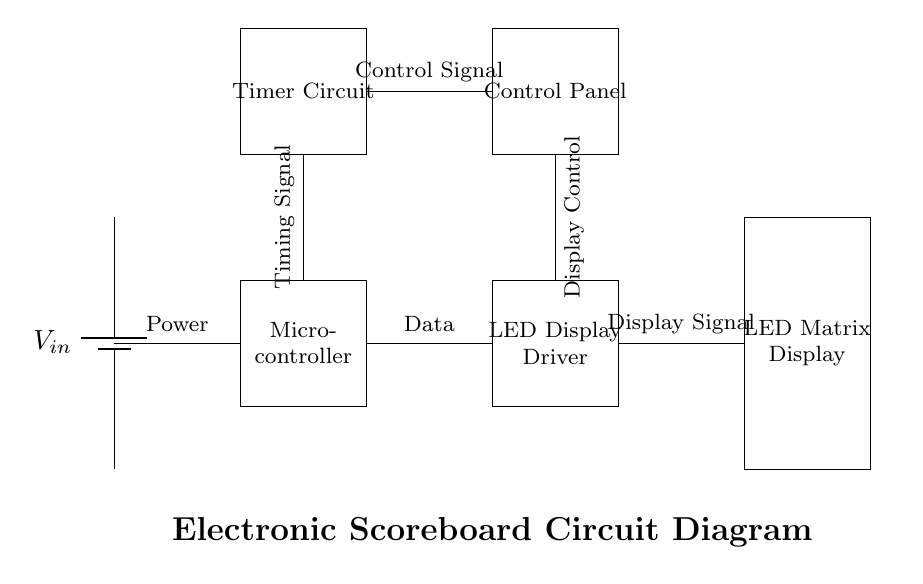What is the main function of the micro-controller in this circuit? The micro-controller processes data and sends control signals to both the LED display driver and the timer circuit, orchestrating the scoreboard's operations.
Answer: Data processing What type of display is utilized in this circuit? The circuit features an LED matrix display, indicated by the labeled rectangle representing this component in the diagram.
Answer: LED matrix display How many main components are present in the circuit diagram? By counting the rectangular shapes representing components, we identify five primary components: power supply, micro-controller, LED display driver, LED matrix display, and timer circuit.
Answer: Five What is the role of the timer circuit in the electronic scoreboard? The timer circuit is responsible for generating timing signals, which are crucial for operations such as keeping score and measuring time during games.
Answer: Timing signals Which component receives control signals from the control panel? The connection from the control panel to the timer circuit indicates that the timer circuit receives control signals to manage time-related functions.
Answer: Timer circuit What type of signal does the LED display driver utilize? The LED display driver utilizes display signals to control the LED matrix display, as shown in the connections leading to the display component.
Answer: Display signals 